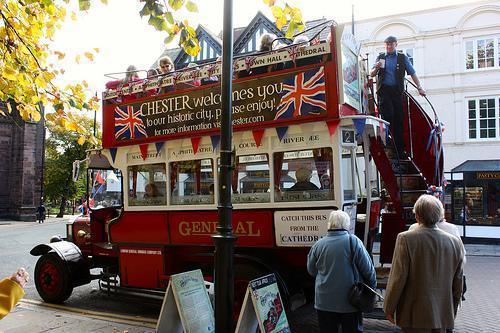How many levels does the truck have?
Give a very brief answer. 2. 